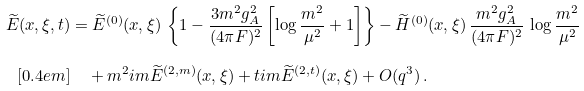Convert formula to latex. <formula><loc_0><loc_0><loc_500><loc_500>\widetilde { E } ( x , \xi , t ) & = \widetilde { E } ^ { ( 0 ) } ( x , \xi ) \, \left \{ 1 - \frac { 3 m ^ { 2 } g _ { A } ^ { 2 } } { ( 4 \pi F ) ^ { 2 } } \left [ \log \frac { m ^ { 2 } } { \mu ^ { 2 } } + 1 \right ] \right \} - \widetilde { H } ^ { ( 0 ) } ( x , \xi ) \, \frac { m ^ { 2 } g _ { A } ^ { 2 } } { ( 4 \pi F ) ^ { 2 } } \, \log \frac { m ^ { 2 } } { \mu ^ { 2 } } \\ [ 0 . 4 e m ] & \quad + m ^ { 2 } \sl i m \widetilde { E } ^ { ( 2 , m ) } ( x , \xi ) + t \sl i m \widetilde { E } ^ { ( 2 , t ) } ( x , \xi ) + O ( q ^ { 3 } ) \, .</formula> 